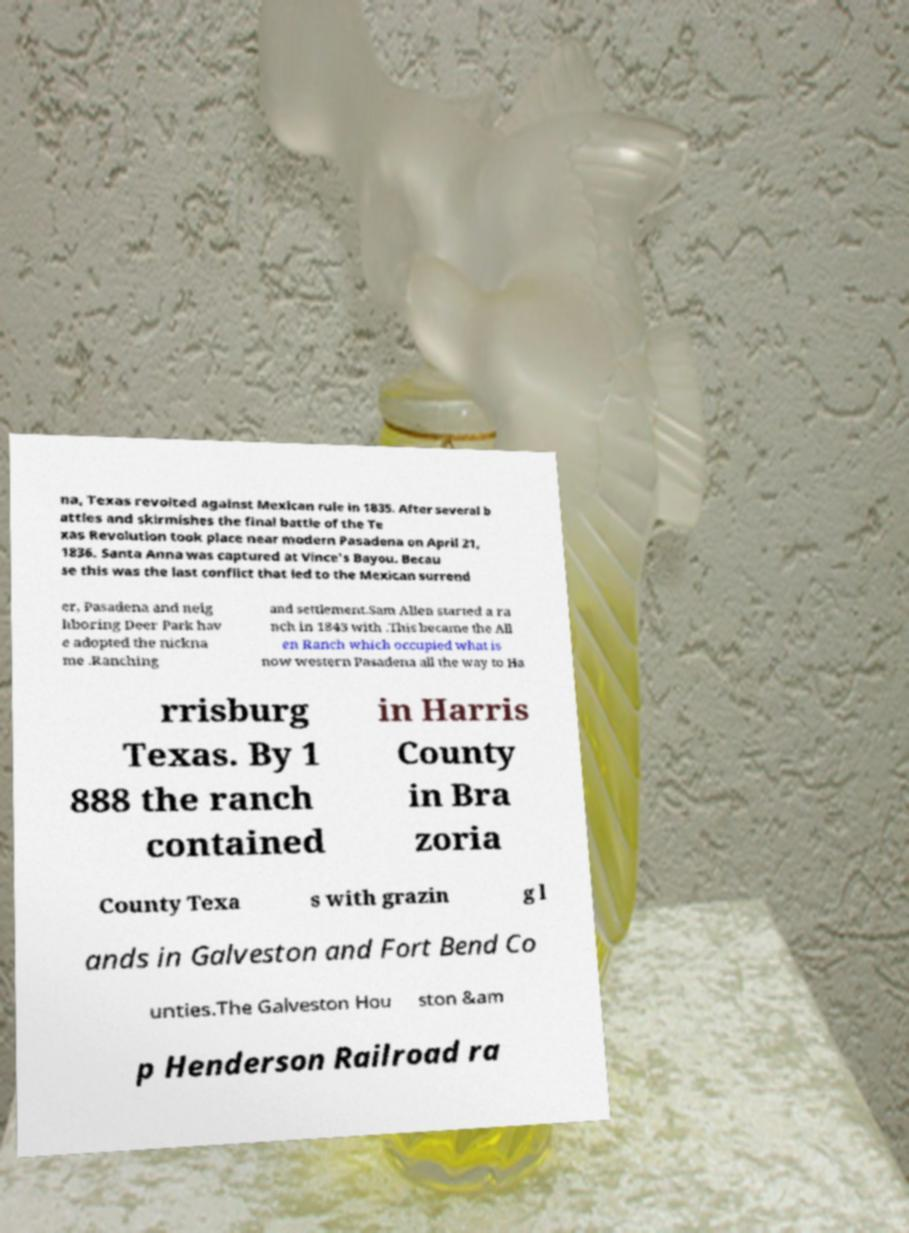Could you assist in decoding the text presented in this image and type it out clearly? na, Texas revolted against Mexican rule in 1835. After several b attles and skirmishes the final battle of the Te xas Revolution took place near modern Pasadena on April 21, 1836. Santa Anna was captured at Vince's Bayou. Becau se this was the last conflict that led to the Mexican surrend er, Pasadena and neig hboring Deer Park hav e adopted the nickna me .Ranching and settlement.Sam Allen started a ra nch in 1843 with .This became the All en Ranch which occupied what is now western Pasadena all the way to Ha rrisburg Texas. By 1 888 the ranch contained in Harris County in Bra zoria County Texa s with grazin g l ands in Galveston and Fort Bend Co unties.The Galveston Hou ston &am p Henderson Railroad ra 